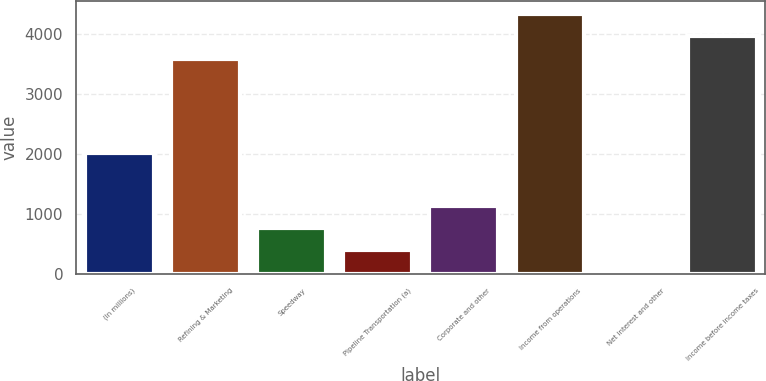<chart> <loc_0><loc_0><loc_500><loc_500><bar_chart><fcel>(In millions)<fcel>Refining & Marketing<fcel>Speedway<fcel>Pipeline Transportation (a)<fcel>Corporate and other<fcel>Income from operations<fcel>Net interest and other<fcel>Income before income taxes<nl><fcel>2011<fcel>3591<fcel>769.8<fcel>397.9<fcel>1141.7<fcel>4334.8<fcel>26<fcel>3962.9<nl></chart> 